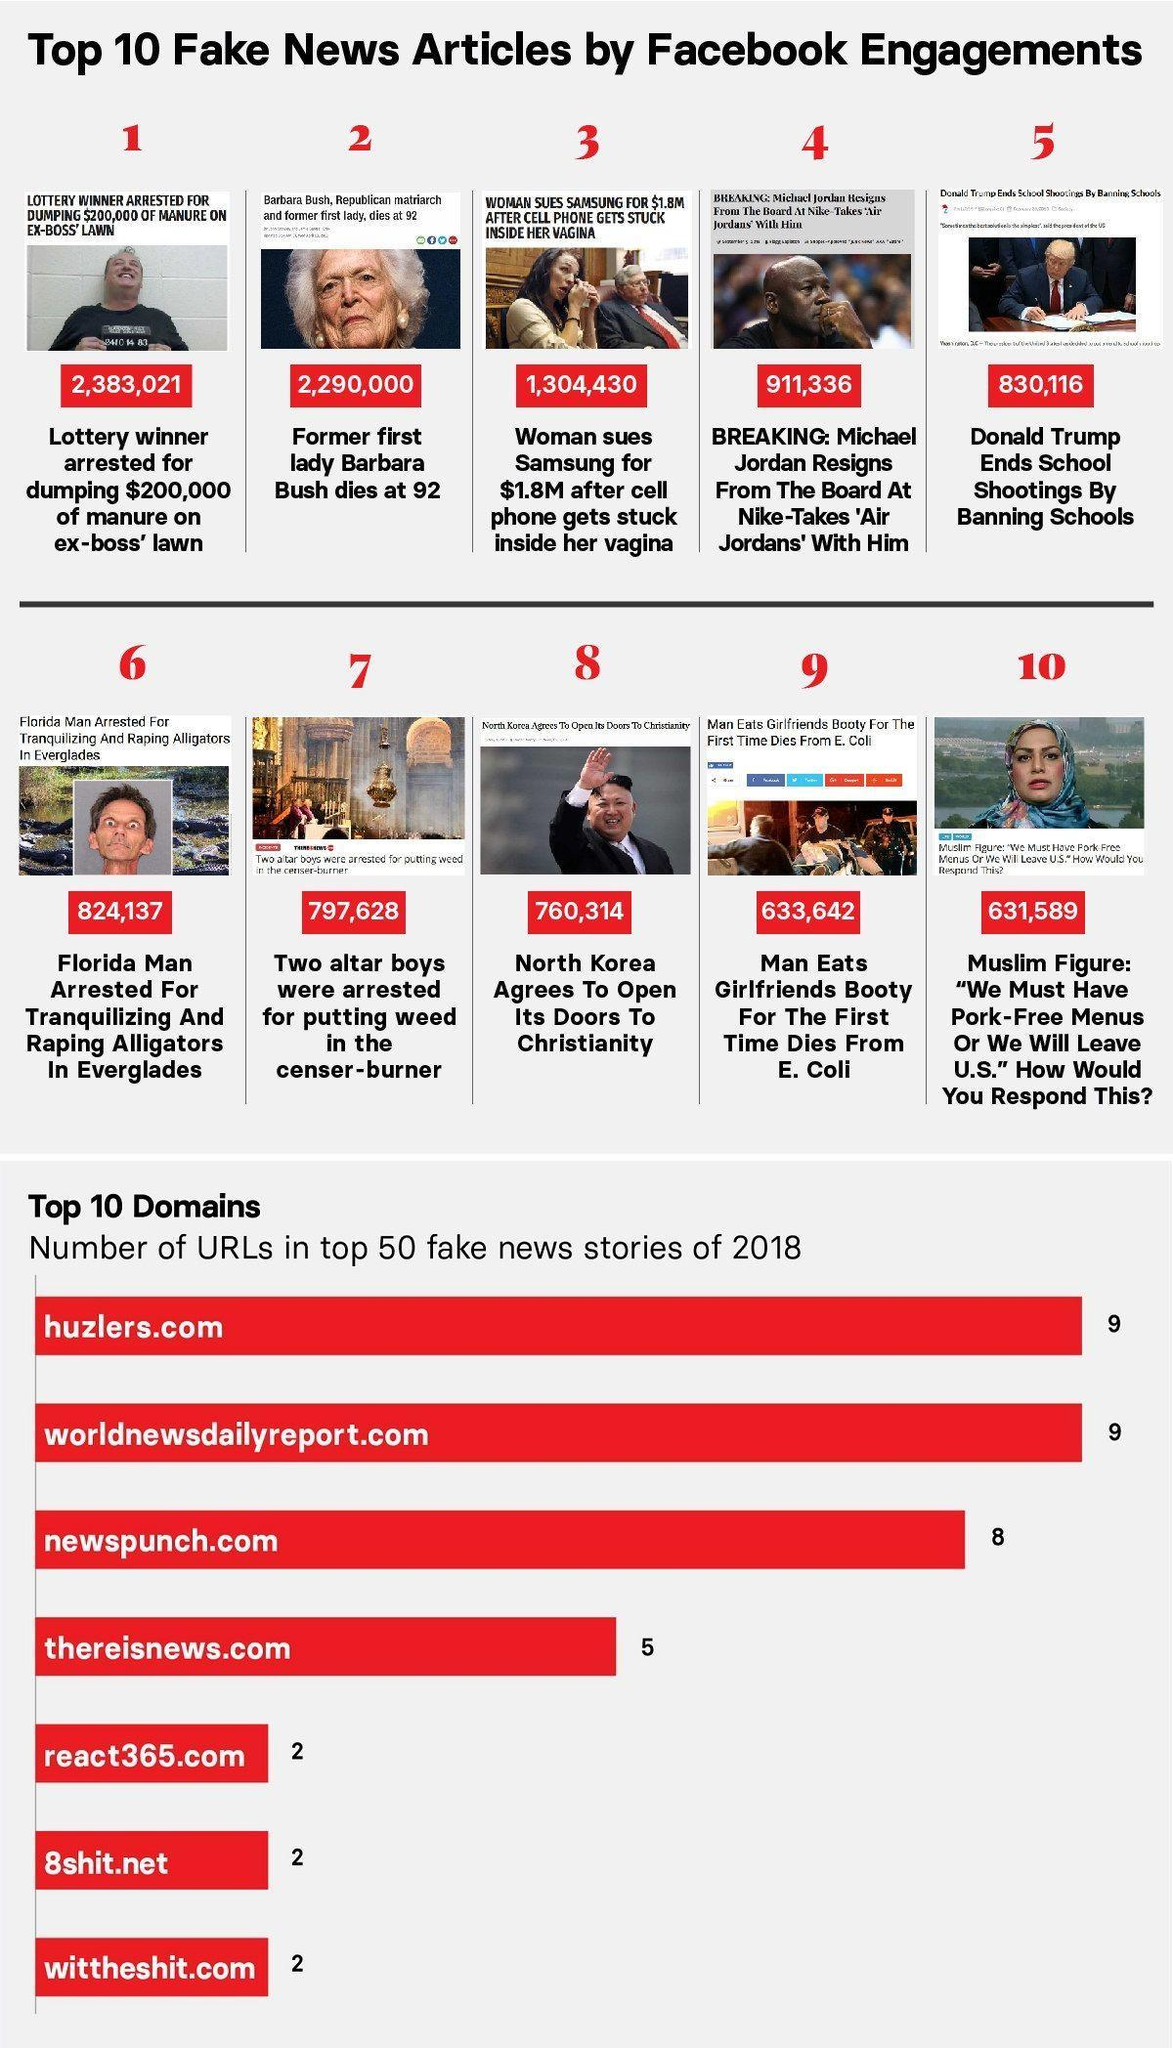What is the number of URLs in huzlers.com and wittheshit.com, taken together?
Answer the question with a short phrase. 11 What is the number of URLs in newspunch.com and thereisnews.com, taken together? 13 What is the number of URLs in react365.com and 8shit.net, taken together? 4 